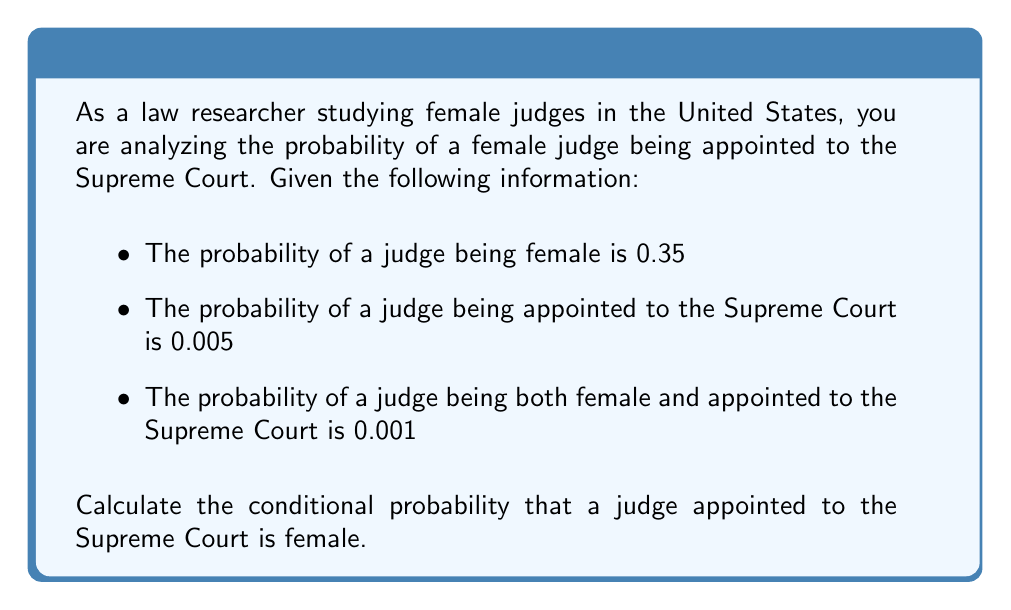Show me your answer to this math problem. To solve this problem, we'll use the formula for conditional probability:

$$ P(A|B) = \frac{P(A \cap B)}{P(B)} $$

Where:
A = event of a judge being female
B = event of a judge being appointed to the Supreme Court

We are given:
$P(A) = 0.35$
$P(B) = 0.005$
$P(A \cap B) = 0.001$

Plugging these values into the conditional probability formula:

$$ P(A|B) = \frac{P(A \cap B)}{P(B)} = \frac{0.001}{0.005} $$

Simplifying:

$$ P(A|B) = \frac{1}{5} = 0.2 $$

Therefore, the conditional probability that a judge appointed to the Supreme Court is female is 0.2 or 20%.

This result indicates that while only 0.5% of all judges are appointed to the Supreme Court, 20% of those appointed are female. This is lower than the overall percentage of female judges (35%), suggesting that female judges are underrepresented in Supreme Court appointments relative to their presence in the judiciary as a whole.
Answer: The conditional probability that a judge appointed to the Supreme Court is female is 0.2 or 20%. 